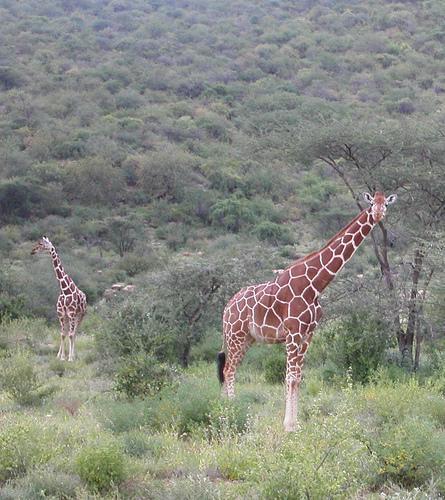How many giraffes are there?
Give a very brief answer. 2. How many giraffes are in the picture?
Give a very brief answer. 2. 